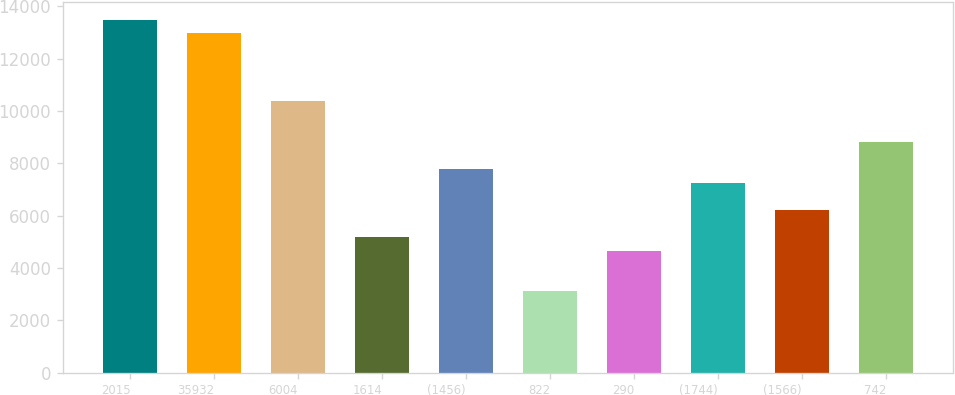Convert chart. <chart><loc_0><loc_0><loc_500><loc_500><bar_chart><fcel>2015<fcel>35932<fcel>6004<fcel>1614<fcel>(1456)<fcel>822<fcel>290<fcel>(1744)<fcel>(1566)<fcel>742<nl><fcel>13487.7<fcel>12969.1<fcel>10376.1<fcel>5190.1<fcel>7783.1<fcel>3115.7<fcel>4671.5<fcel>7264.5<fcel>6227.3<fcel>8820.3<nl></chart> 